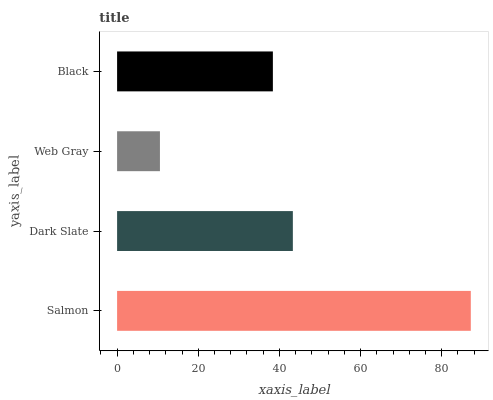Is Web Gray the minimum?
Answer yes or no. Yes. Is Salmon the maximum?
Answer yes or no. Yes. Is Dark Slate the minimum?
Answer yes or no. No. Is Dark Slate the maximum?
Answer yes or no. No. Is Salmon greater than Dark Slate?
Answer yes or no. Yes. Is Dark Slate less than Salmon?
Answer yes or no. Yes. Is Dark Slate greater than Salmon?
Answer yes or no. No. Is Salmon less than Dark Slate?
Answer yes or no. No. Is Dark Slate the high median?
Answer yes or no. Yes. Is Black the low median?
Answer yes or no. Yes. Is Black the high median?
Answer yes or no. No. Is Web Gray the low median?
Answer yes or no. No. 